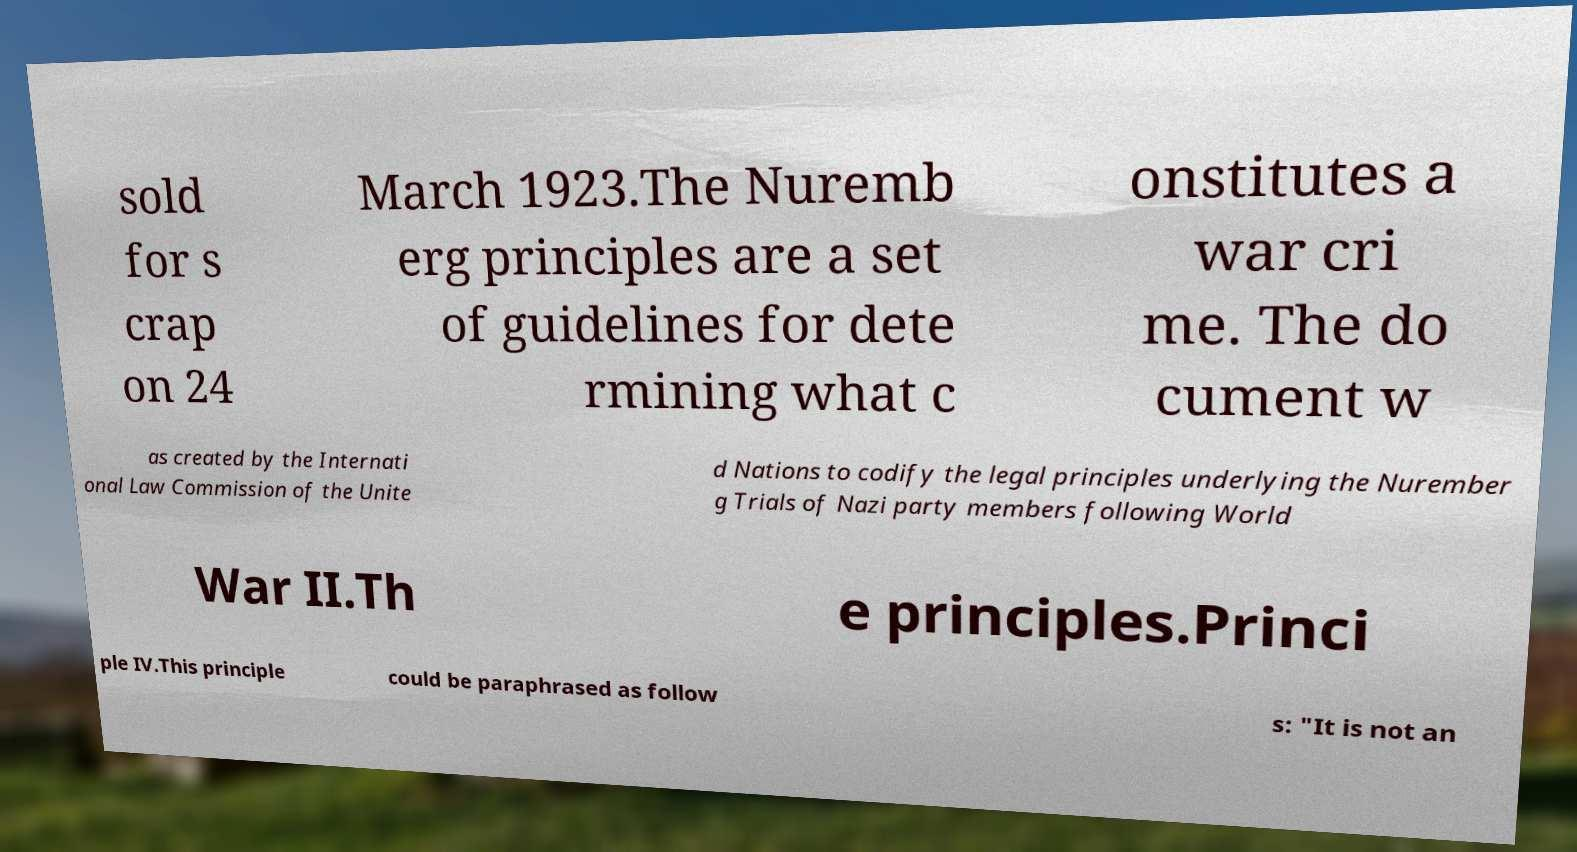Could you extract and type out the text from this image? sold for s crap on 24 March 1923.The Nuremb erg principles are a set of guidelines for dete rmining what c onstitutes a war cri me. The do cument w as created by the Internati onal Law Commission of the Unite d Nations to codify the legal principles underlying the Nurember g Trials of Nazi party members following World War II.Th e principles.Princi ple IV.This principle could be paraphrased as follow s: "It is not an 